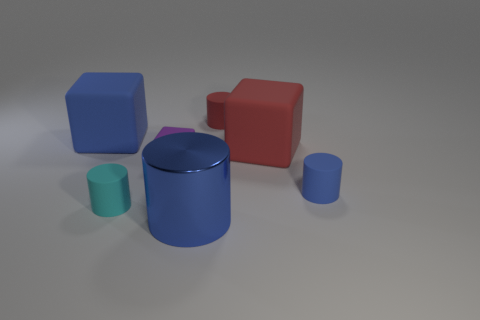Add 1 tiny cyan balls. How many objects exist? 8 Subtract all tiny blocks. How many blocks are left? 2 Subtract all green balls. How many blue cylinders are left? 2 Subtract 3 cylinders. How many cylinders are left? 1 Subtract all blue cubes. How many cubes are left? 2 Subtract all cubes. How many objects are left? 4 Add 5 big rubber blocks. How many big rubber blocks exist? 7 Subtract 0 cyan cubes. How many objects are left? 7 Subtract all blue cylinders. Subtract all cyan blocks. How many cylinders are left? 2 Subtract all big metal cylinders. Subtract all tiny red rubber cylinders. How many objects are left? 5 